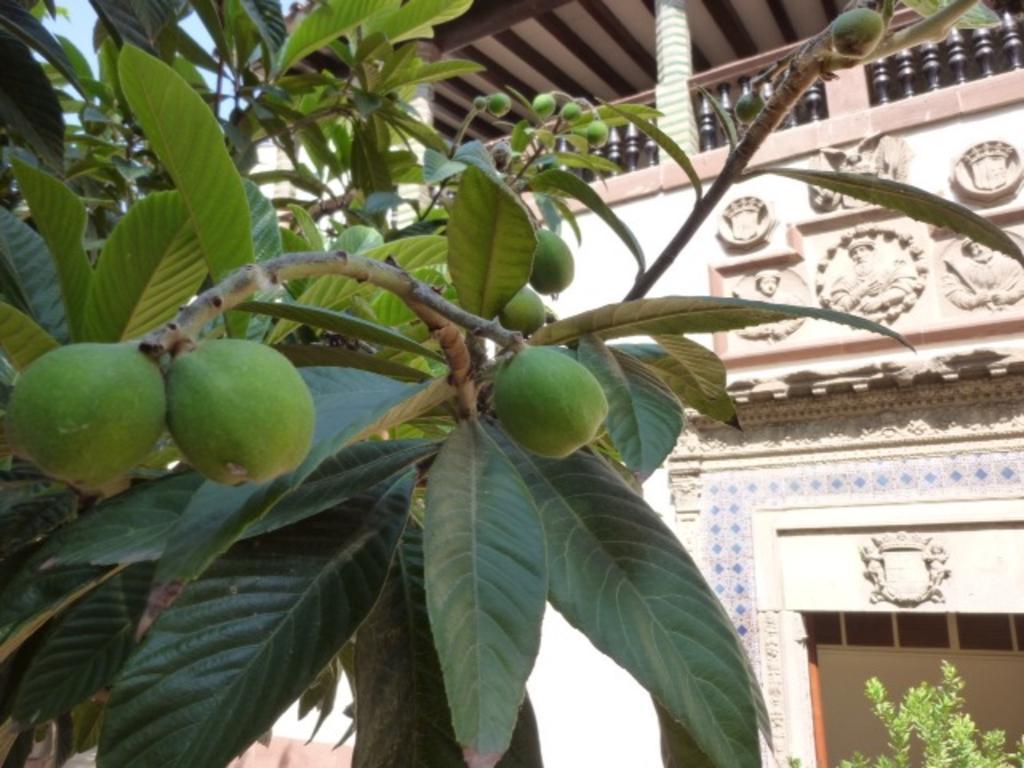Please provide a concise description of this image. In front of the picture, we see the tree which has fruits and these fruits are in green color. In the right bottom, we see a plant. In the background, we see a building in white color. We even see the pillars, railing and the roof of the building. 